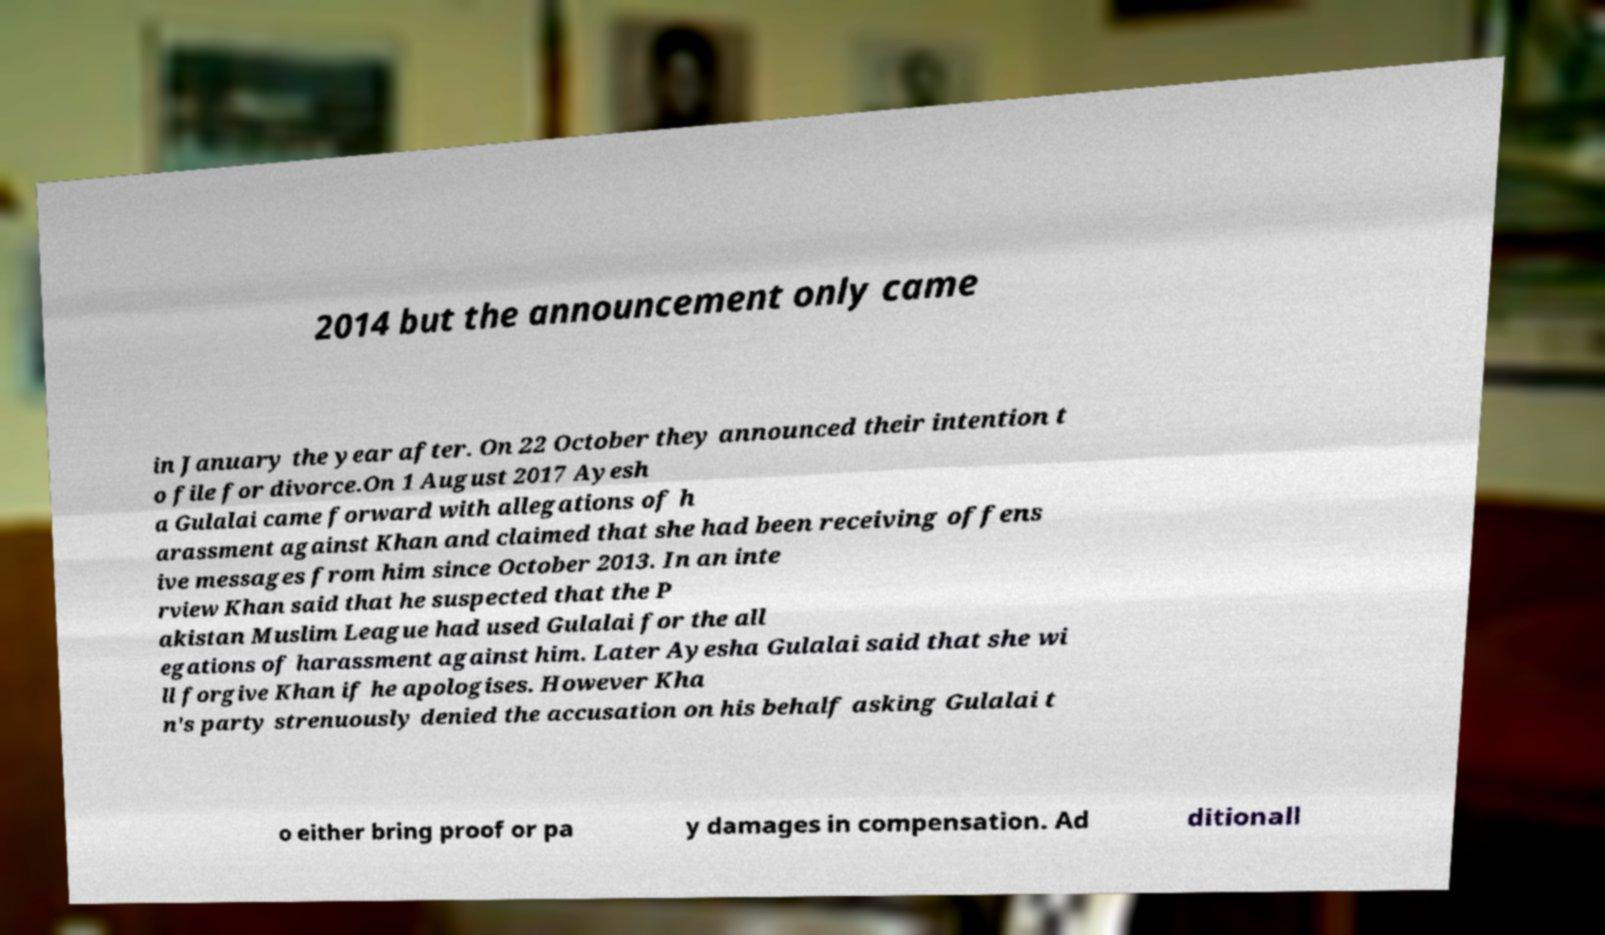Please identify and transcribe the text found in this image. 2014 but the announcement only came in January the year after. On 22 October they announced their intention t o file for divorce.On 1 August 2017 Ayesh a Gulalai came forward with allegations of h arassment against Khan and claimed that she had been receiving offens ive messages from him since October 2013. In an inte rview Khan said that he suspected that the P akistan Muslim League had used Gulalai for the all egations of harassment against him. Later Ayesha Gulalai said that she wi ll forgive Khan if he apologises. However Kha n's party strenuously denied the accusation on his behalf asking Gulalai t o either bring proof or pa y damages in compensation. Ad ditionall 